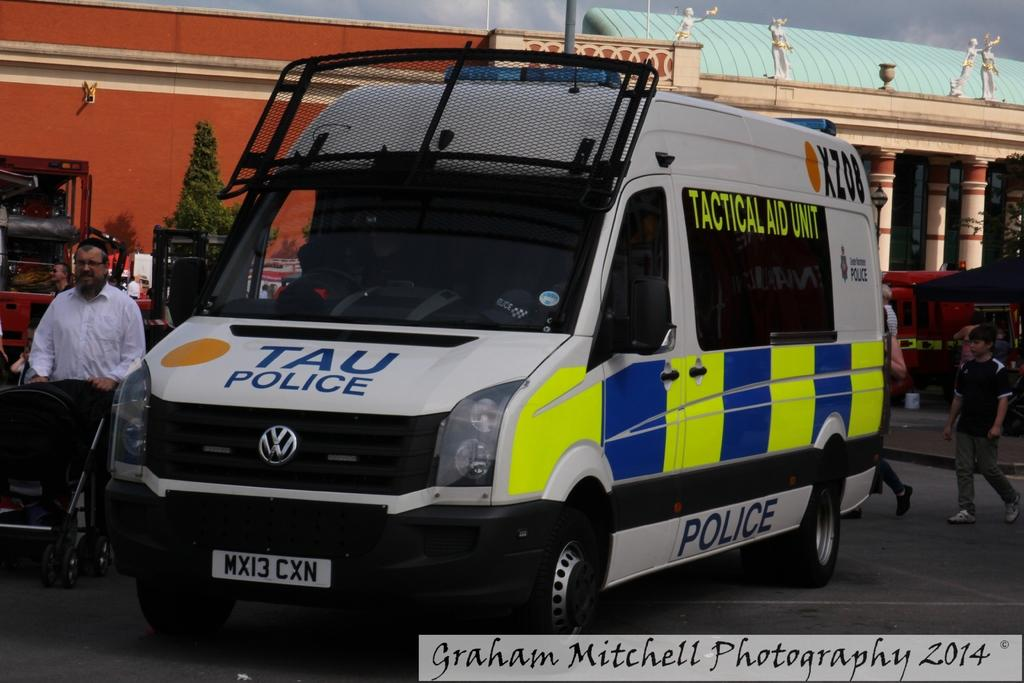<image>
Write a terse but informative summary of the picture. White van that says TAU POLICE on the hood of the car. 